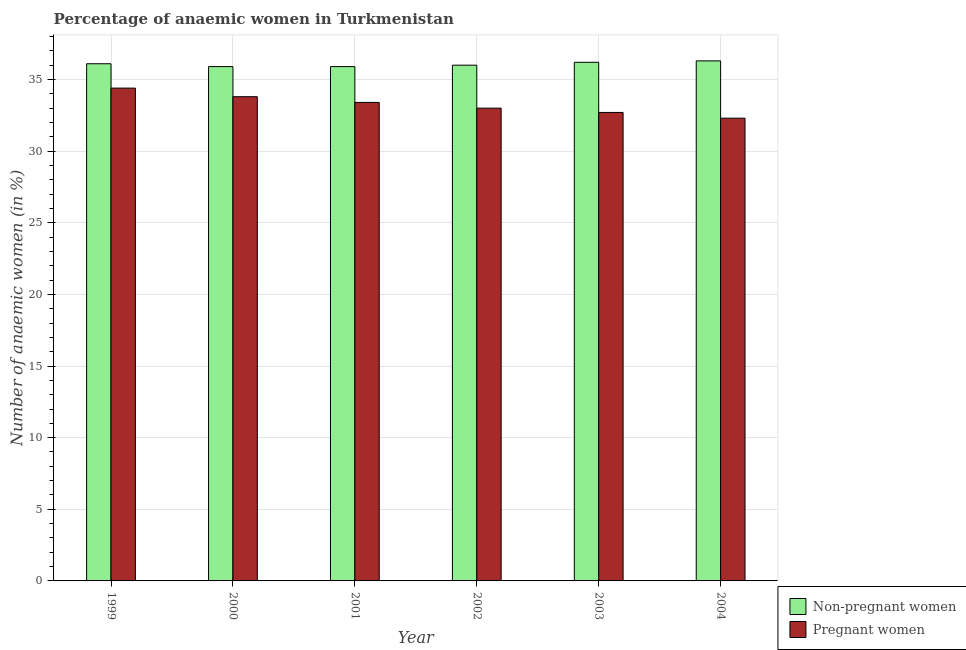Are the number of bars on each tick of the X-axis equal?
Provide a succinct answer. Yes. What is the percentage of pregnant anaemic women in 2004?
Make the answer very short. 32.3. Across all years, what is the maximum percentage of non-pregnant anaemic women?
Give a very brief answer. 36.3. Across all years, what is the minimum percentage of non-pregnant anaemic women?
Your response must be concise. 35.9. In which year was the percentage of pregnant anaemic women minimum?
Your answer should be very brief. 2004. What is the total percentage of non-pregnant anaemic women in the graph?
Make the answer very short. 216.4. What is the difference between the percentage of pregnant anaemic women in 2001 and that in 2004?
Offer a very short reply. 1.1. What is the difference between the percentage of pregnant anaemic women in 2003 and the percentage of non-pregnant anaemic women in 2002?
Offer a very short reply. -0.3. What is the average percentage of non-pregnant anaemic women per year?
Provide a short and direct response. 36.07. In how many years, is the percentage of non-pregnant anaemic women greater than 21 %?
Offer a terse response. 6. What is the ratio of the percentage of non-pregnant anaemic women in 1999 to that in 2000?
Provide a succinct answer. 1.01. What is the difference between the highest and the second highest percentage of non-pregnant anaemic women?
Your answer should be very brief. 0.1. What is the difference between the highest and the lowest percentage of pregnant anaemic women?
Your answer should be compact. 2.1. Is the sum of the percentage of non-pregnant anaemic women in 1999 and 2003 greater than the maximum percentage of pregnant anaemic women across all years?
Your response must be concise. Yes. What does the 2nd bar from the left in 2002 represents?
Your response must be concise. Pregnant women. What does the 1st bar from the right in 2000 represents?
Provide a succinct answer. Pregnant women. Are all the bars in the graph horizontal?
Your response must be concise. No. What is the difference between two consecutive major ticks on the Y-axis?
Provide a short and direct response. 5. Are the values on the major ticks of Y-axis written in scientific E-notation?
Your answer should be compact. No. Where does the legend appear in the graph?
Offer a terse response. Bottom right. What is the title of the graph?
Keep it short and to the point. Percentage of anaemic women in Turkmenistan. What is the label or title of the X-axis?
Provide a succinct answer. Year. What is the label or title of the Y-axis?
Provide a succinct answer. Number of anaemic women (in %). What is the Number of anaemic women (in %) of Non-pregnant women in 1999?
Offer a terse response. 36.1. What is the Number of anaemic women (in %) in Pregnant women in 1999?
Provide a succinct answer. 34.4. What is the Number of anaemic women (in %) in Non-pregnant women in 2000?
Your answer should be very brief. 35.9. What is the Number of anaemic women (in %) in Pregnant women in 2000?
Your answer should be very brief. 33.8. What is the Number of anaemic women (in %) in Non-pregnant women in 2001?
Provide a succinct answer. 35.9. What is the Number of anaemic women (in %) in Pregnant women in 2001?
Provide a short and direct response. 33.4. What is the Number of anaemic women (in %) in Non-pregnant women in 2002?
Provide a succinct answer. 36. What is the Number of anaemic women (in %) of Pregnant women in 2002?
Offer a very short reply. 33. What is the Number of anaemic women (in %) of Non-pregnant women in 2003?
Provide a short and direct response. 36.2. What is the Number of anaemic women (in %) of Pregnant women in 2003?
Make the answer very short. 32.7. What is the Number of anaemic women (in %) of Non-pregnant women in 2004?
Offer a terse response. 36.3. What is the Number of anaemic women (in %) in Pregnant women in 2004?
Your answer should be very brief. 32.3. Across all years, what is the maximum Number of anaemic women (in %) of Non-pregnant women?
Offer a terse response. 36.3. Across all years, what is the maximum Number of anaemic women (in %) in Pregnant women?
Give a very brief answer. 34.4. Across all years, what is the minimum Number of anaemic women (in %) of Non-pregnant women?
Offer a terse response. 35.9. Across all years, what is the minimum Number of anaemic women (in %) in Pregnant women?
Ensure brevity in your answer.  32.3. What is the total Number of anaemic women (in %) of Non-pregnant women in the graph?
Your response must be concise. 216.4. What is the total Number of anaemic women (in %) in Pregnant women in the graph?
Offer a very short reply. 199.6. What is the difference between the Number of anaemic women (in %) in Pregnant women in 1999 and that in 2001?
Ensure brevity in your answer.  1. What is the difference between the Number of anaemic women (in %) in Non-pregnant women in 1999 and that in 2002?
Make the answer very short. 0.1. What is the difference between the Number of anaemic women (in %) in Pregnant women in 1999 and that in 2002?
Your answer should be very brief. 1.4. What is the difference between the Number of anaemic women (in %) in Pregnant women in 1999 and that in 2003?
Your answer should be compact. 1.7. What is the difference between the Number of anaemic women (in %) of Pregnant women in 2000 and that in 2001?
Your answer should be very brief. 0.4. What is the difference between the Number of anaemic women (in %) in Pregnant women in 2001 and that in 2002?
Ensure brevity in your answer.  0.4. What is the difference between the Number of anaemic women (in %) of Non-pregnant women in 2002 and that in 2003?
Make the answer very short. -0.2. What is the difference between the Number of anaemic women (in %) in Non-pregnant women in 2002 and that in 2004?
Your answer should be compact. -0.3. What is the difference between the Number of anaemic women (in %) of Pregnant women in 2003 and that in 2004?
Provide a succinct answer. 0.4. What is the difference between the Number of anaemic women (in %) in Non-pregnant women in 1999 and the Number of anaemic women (in %) in Pregnant women in 2001?
Provide a short and direct response. 2.7. What is the difference between the Number of anaemic women (in %) of Non-pregnant women in 1999 and the Number of anaemic women (in %) of Pregnant women in 2002?
Offer a very short reply. 3.1. What is the difference between the Number of anaemic women (in %) in Non-pregnant women in 2000 and the Number of anaemic women (in %) in Pregnant women in 2002?
Make the answer very short. 2.9. What is the difference between the Number of anaemic women (in %) in Non-pregnant women in 2001 and the Number of anaemic women (in %) in Pregnant women in 2004?
Provide a short and direct response. 3.6. What is the difference between the Number of anaemic women (in %) in Non-pregnant women in 2002 and the Number of anaemic women (in %) in Pregnant women in 2003?
Your response must be concise. 3.3. What is the difference between the Number of anaemic women (in %) of Non-pregnant women in 2002 and the Number of anaemic women (in %) of Pregnant women in 2004?
Your response must be concise. 3.7. What is the difference between the Number of anaemic women (in %) of Non-pregnant women in 2003 and the Number of anaemic women (in %) of Pregnant women in 2004?
Give a very brief answer. 3.9. What is the average Number of anaemic women (in %) of Non-pregnant women per year?
Provide a succinct answer. 36.07. What is the average Number of anaemic women (in %) of Pregnant women per year?
Make the answer very short. 33.27. In the year 1999, what is the difference between the Number of anaemic women (in %) in Non-pregnant women and Number of anaemic women (in %) in Pregnant women?
Provide a succinct answer. 1.7. In the year 2000, what is the difference between the Number of anaemic women (in %) in Non-pregnant women and Number of anaemic women (in %) in Pregnant women?
Give a very brief answer. 2.1. In the year 2002, what is the difference between the Number of anaemic women (in %) in Non-pregnant women and Number of anaemic women (in %) in Pregnant women?
Your answer should be very brief. 3. In the year 2003, what is the difference between the Number of anaemic women (in %) of Non-pregnant women and Number of anaemic women (in %) of Pregnant women?
Keep it short and to the point. 3.5. What is the ratio of the Number of anaemic women (in %) in Non-pregnant women in 1999 to that in 2000?
Keep it short and to the point. 1.01. What is the ratio of the Number of anaemic women (in %) in Pregnant women in 1999 to that in 2000?
Ensure brevity in your answer.  1.02. What is the ratio of the Number of anaemic women (in %) in Non-pregnant women in 1999 to that in 2001?
Your answer should be very brief. 1.01. What is the ratio of the Number of anaemic women (in %) in Pregnant women in 1999 to that in 2001?
Keep it short and to the point. 1.03. What is the ratio of the Number of anaemic women (in %) in Pregnant women in 1999 to that in 2002?
Provide a short and direct response. 1.04. What is the ratio of the Number of anaemic women (in %) in Non-pregnant women in 1999 to that in 2003?
Keep it short and to the point. 1. What is the ratio of the Number of anaemic women (in %) of Pregnant women in 1999 to that in 2003?
Your response must be concise. 1.05. What is the ratio of the Number of anaemic women (in %) in Pregnant women in 1999 to that in 2004?
Provide a short and direct response. 1.06. What is the ratio of the Number of anaemic women (in %) in Pregnant women in 2000 to that in 2001?
Your answer should be compact. 1.01. What is the ratio of the Number of anaemic women (in %) of Non-pregnant women in 2000 to that in 2002?
Your answer should be compact. 1. What is the ratio of the Number of anaemic women (in %) of Pregnant women in 2000 to that in 2002?
Keep it short and to the point. 1.02. What is the ratio of the Number of anaemic women (in %) of Pregnant women in 2000 to that in 2003?
Offer a very short reply. 1.03. What is the ratio of the Number of anaemic women (in %) of Non-pregnant women in 2000 to that in 2004?
Provide a succinct answer. 0.99. What is the ratio of the Number of anaemic women (in %) of Pregnant women in 2000 to that in 2004?
Ensure brevity in your answer.  1.05. What is the ratio of the Number of anaemic women (in %) in Pregnant women in 2001 to that in 2002?
Ensure brevity in your answer.  1.01. What is the ratio of the Number of anaemic women (in %) of Pregnant women in 2001 to that in 2003?
Your response must be concise. 1.02. What is the ratio of the Number of anaemic women (in %) of Non-pregnant women in 2001 to that in 2004?
Keep it short and to the point. 0.99. What is the ratio of the Number of anaemic women (in %) in Pregnant women in 2001 to that in 2004?
Give a very brief answer. 1.03. What is the ratio of the Number of anaemic women (in %) of Non-pregnant women in 2002 to that in 2003?
Give a very brief answer. 0.99. What is the ratio of the Number of anaemic women (in %) in Pregnant women in 2002 to that in 2003?
Your answer should be compact. 1.01. What is the ratio of the Number of anaemic women (in %) in Non-pregnant women in 2002 to that in 2004?
Provide a succinct answer. 0.99. What is the ratio of the Number of anaemic women (in %) in Pregnant women in 2002 to that in 2004?
Provide a succinct answer. 1.02. What is the ratio of the Number of anaemic women (in %) of Pregnant women in 2003 to that in 2004?
Your answer should be very brief. 1.01. What is the difference between the highest and the second highest Number of anaemic women (in %) of Non-pregnant women?
Your answer should be very brief. 0.1. What is the difference between the highest and the second highest Number of anaemic women (in %) of Pregnant women?
Keep it short and to the point. 0.6. What is the difference between the highest and the lowest Number of anaemic women (in %) of Non-pregnant women?
Your answer should be very brief. 0.4. What is the difference between the highest and the lowest Number of anaemic women (in %) in Pregnant women?
Keep it short and to the point. 2.1. 